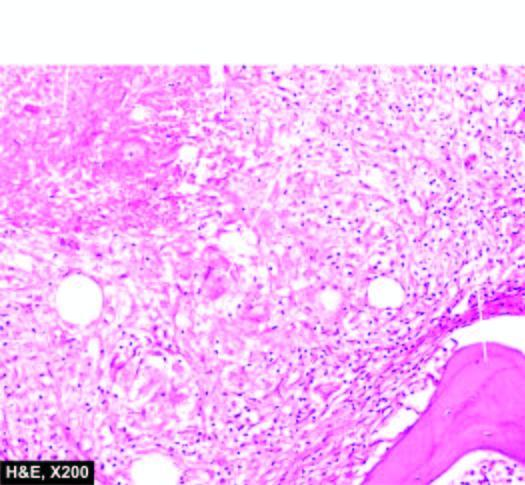what are also seen?
Answer the question using a single word or phrase. Pieces of necrotic bone 